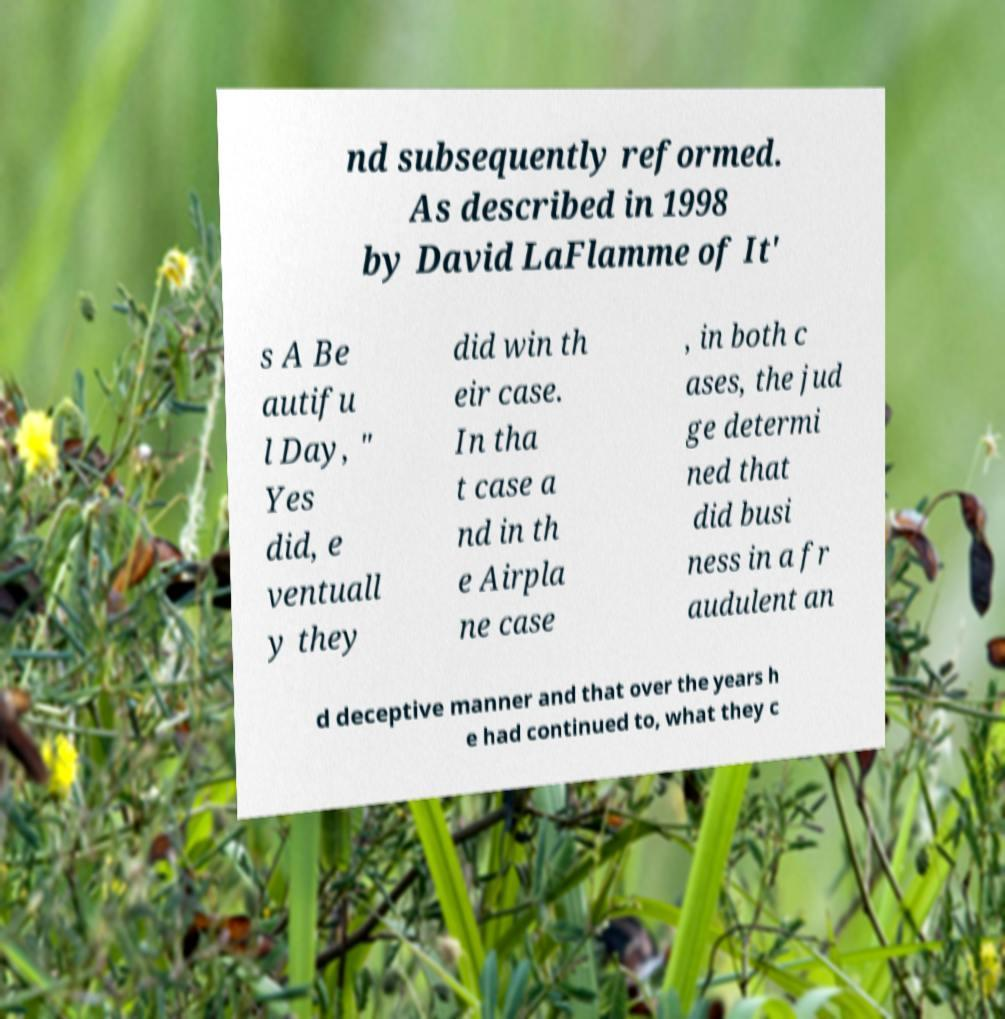Could you extract and type out the text from this image? nd subsequently reformed. As described in 1998 by David LaFlamme of It' s A Be autifu l Day, " Yes did, e ventuall y they did win th eir case. In tha t case a nd in th e Airpla ne case , in both c ases, the jud ge determi ned that did busi ness in a fr audulent an d deceptive manner and that over the years h e had continued to, what they c 